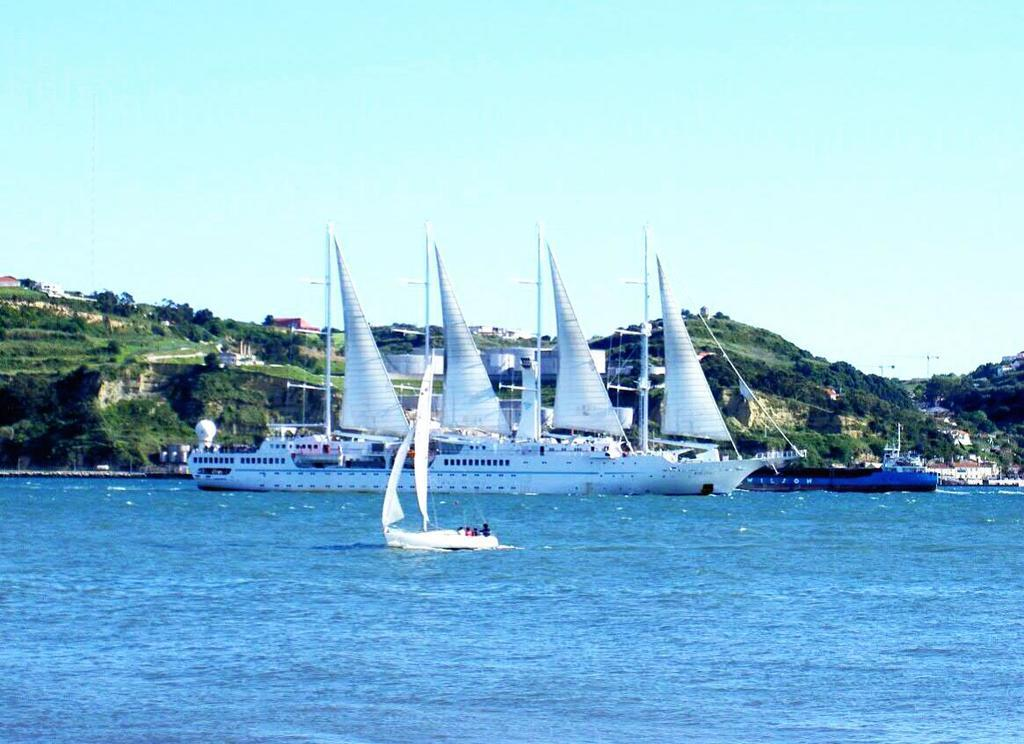What is happening on the water in the image? There are boats on the water in the image. Who is in the boats? There are people sitting in the boats. What can be seen in the background of the image? There are trees in the background of the image. What is the color of the trees? The trees are green. What is the color of the sky in the image? The sky is blue and white in color. What type of manager is overseeing the kitty eating oatmeal in the image? There is no manager, kitty, or oatmeal present in the image. 